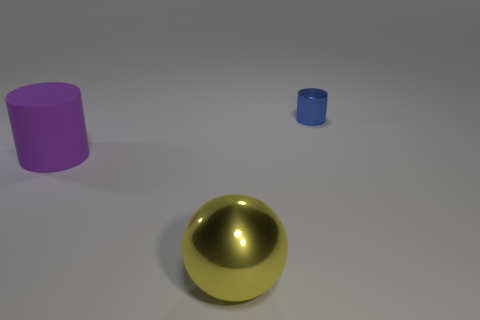Subtract all blue cylinders. How many cylinders are left? 1 Add 2 tiny blue metallic cylinders. How many objects exist? 5 Subtract all spheres. How many objects are left? 2 Subtract 1 spheres. How many spheres are left? 0 Subtract 1 blue cylinders. How many objects are left? 2 Subtract all blue cylinders. Subtract all yellow blocks. How many cylinders are left? 1 Subtract all cyan cylinders. How many green spheres are left? 0 Subtract all big yellow objects. Subtract all green metallic blocks. How many objects are left? 2 Add 3 metallic cylinders. How many metallic cylinders are left? 4 Add 2 small red metallic things. How many small red metallic things exist? 2 